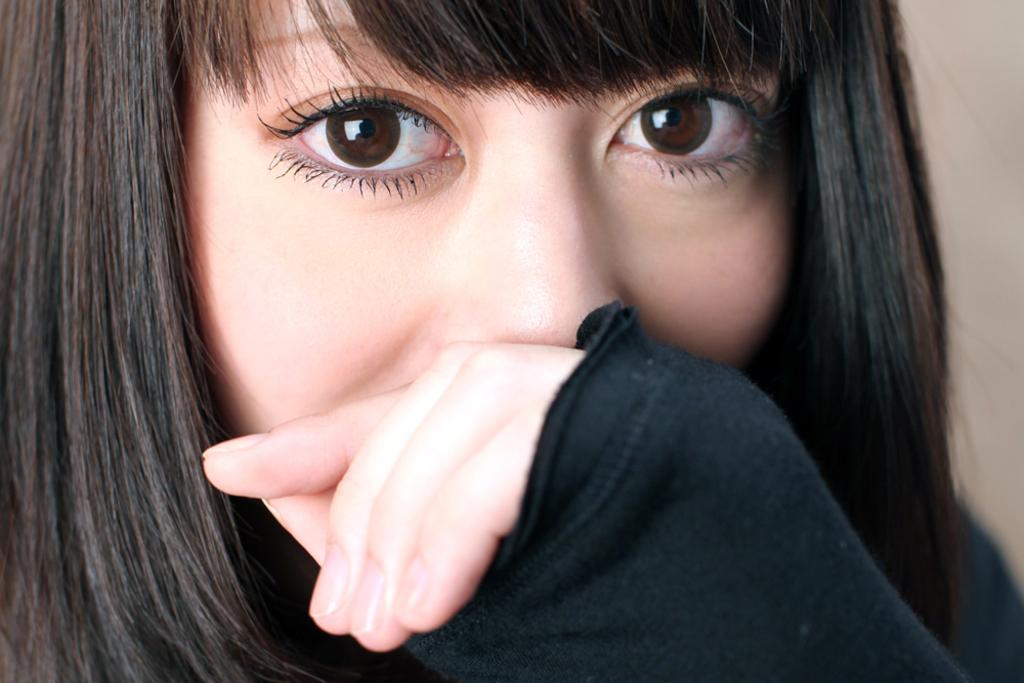What is the main subject of the image? The main subject of the image is a woman. What is the woman wearing in the image? The woman is wearing a dress in the image. What type of vegetable is being used as a hat by the woman in the image? There is no vegetable being used as a hat by the woman in the image. What is the copper content of the dress the woman is wearing? The dress the woman is wearing does not have a copper content, as it is not made of metal. 